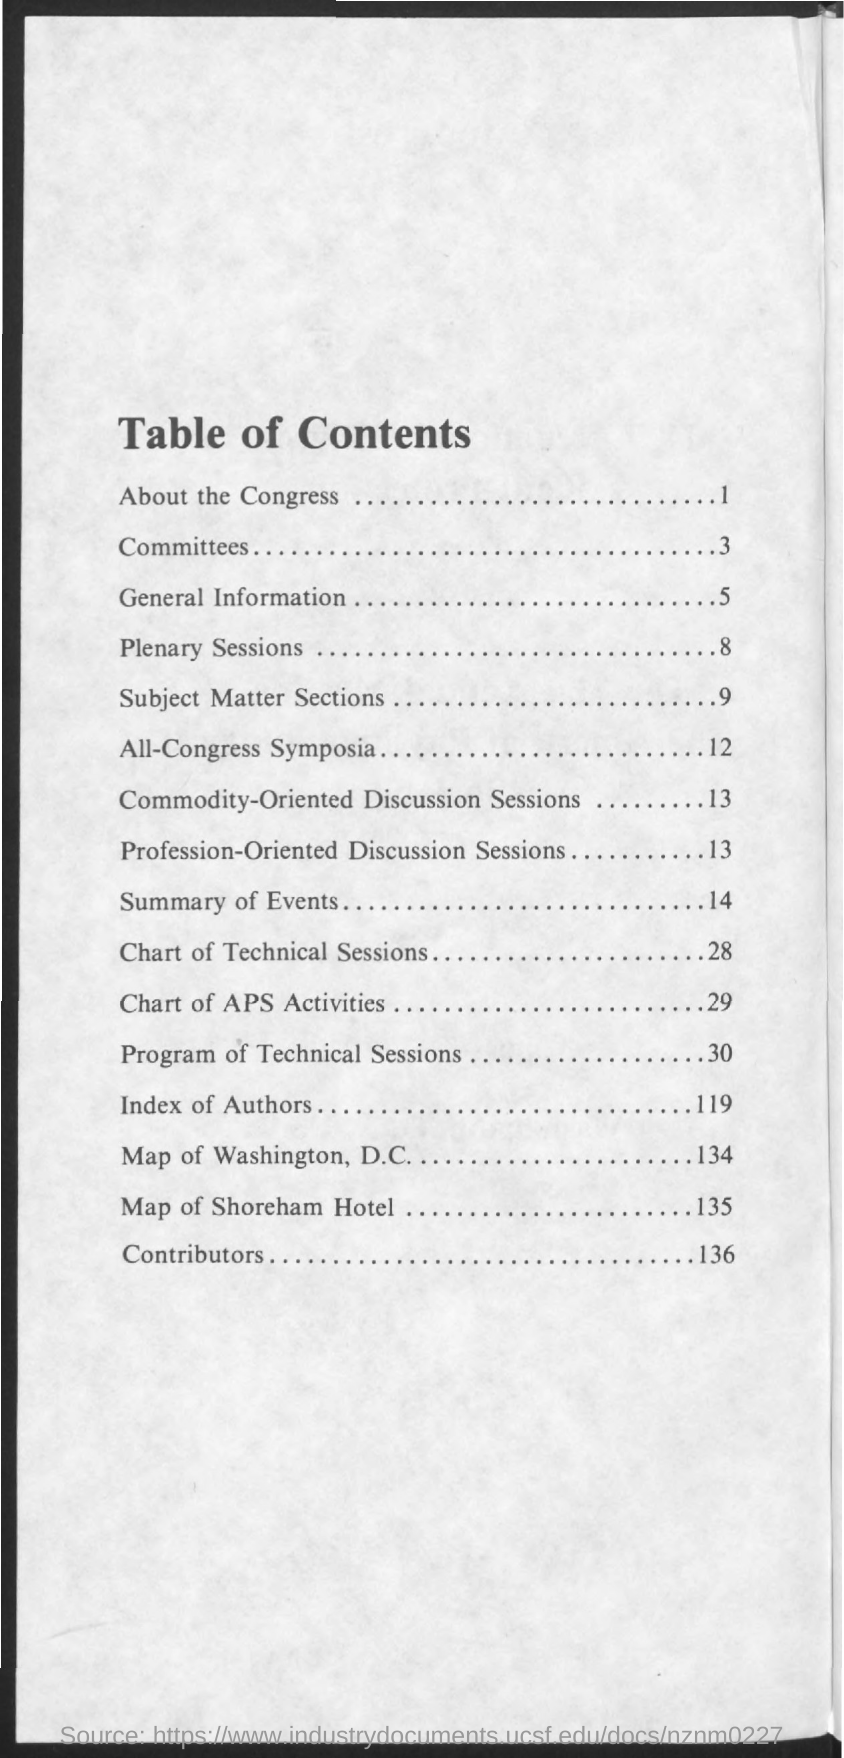What is the title of the document?
Your answer should be very brief. Table of Contents. The topic "Committees" is on which page?
Ensure brevity in your answer.  3. The topic "Contributors" is on which page?
Your response must be concise. 136. Which topic is on page number 119?
Provide a succinct answer. Index of Authors. Which topic is on page number 14?
Keep it short and to the point. Summary of Events. Which topic is on page number 8?
Offer a terse response. Plenary Sessions. 